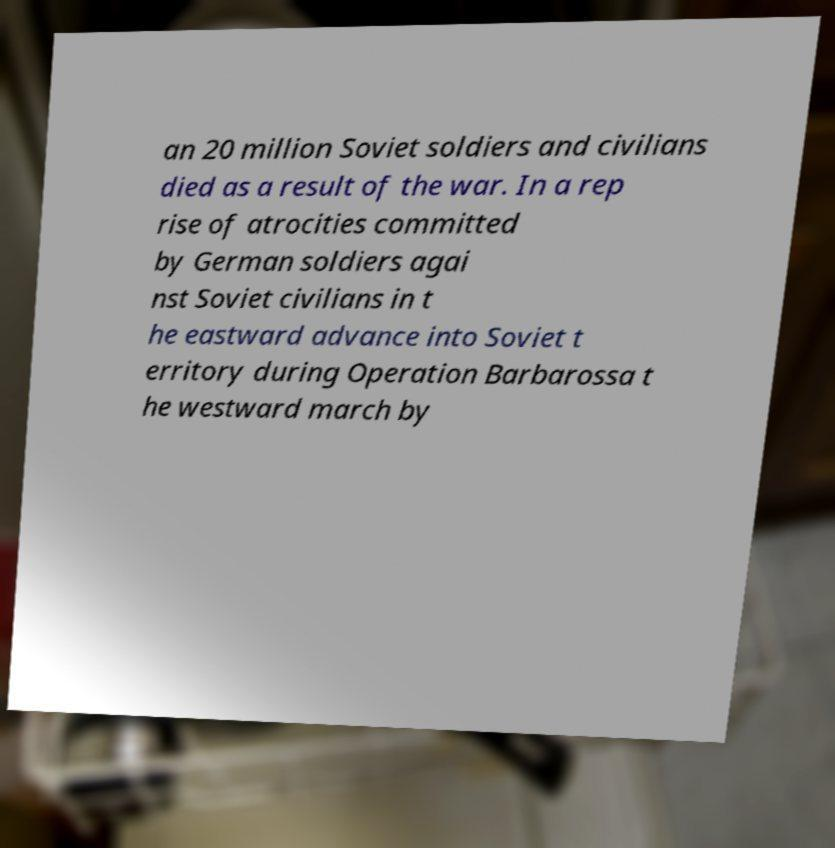Could you extract and type out the text from this image? an 20 million Soviet soldiers and civilians died as a result of the war. In a rep rise of atrocities committed by German soldiers agai nst Soviet civilians in t he eastward advance into Soviet t erritory during Operation Barbarossa t he westward march by 